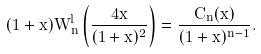<formula> <loc_0><loc_0><loc_500><loc_500>( 1 + x ) W _ { n } ^ { l } \left ( \frac { 4 x } { ( 1 + x ) ^ { 2 } } \right ) = \frac { C _ { n } ( x ) } { ( 1 + x ) ^ { n - 1 } } .</formula> 